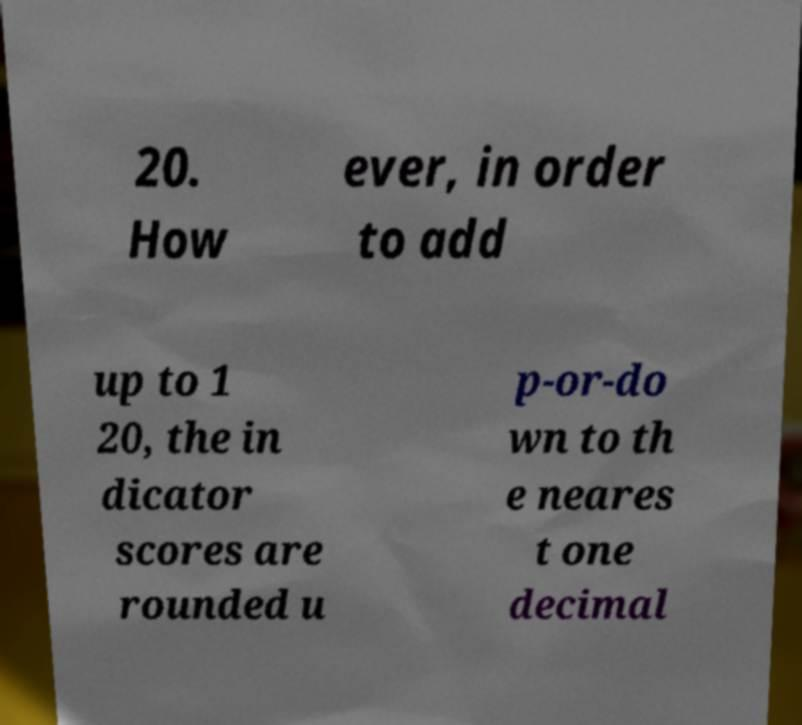There's text embedded in this image that I need extracted. Can you transcribe it verbatim? 20. How ever, in order to add up to 1 20, the in dicator scores are rounded u p-or-do wn to th e neares t one decimal 